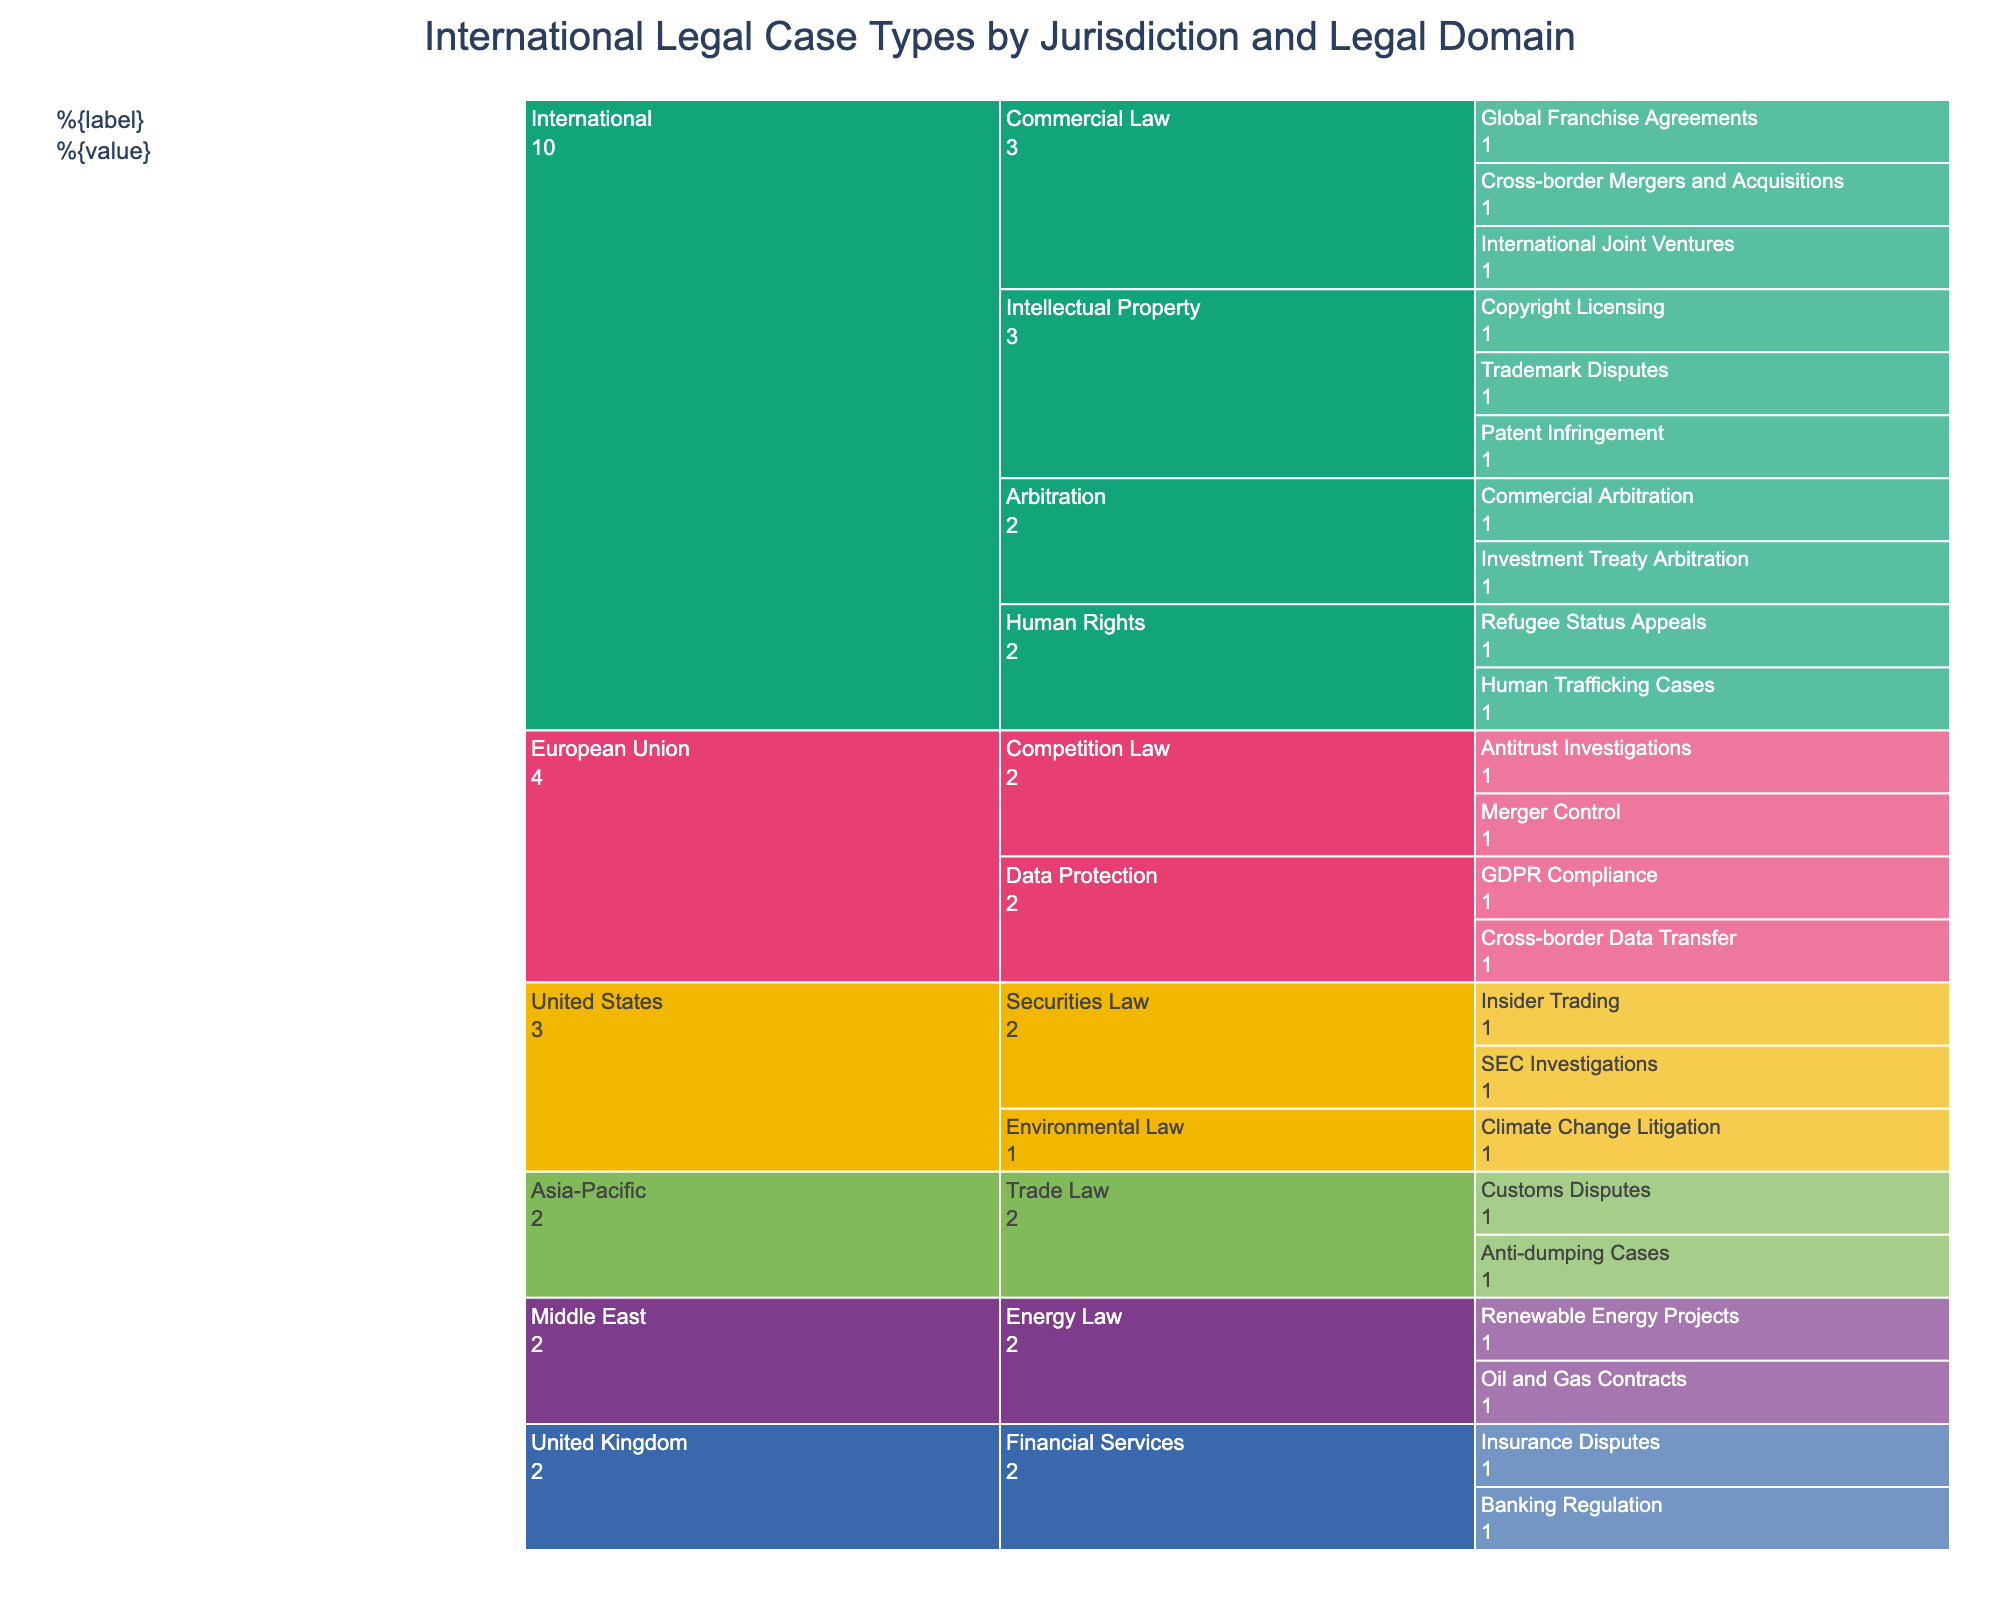What is the title of the icicle chart? The title is located at the top of the chart. It is usually larger and bold to highlight its significance.
Answer: International Legal Case Types by Jurisdiction and Legal Domain Which jurisdiction handles cases related to "Cross-border Mergers and Acquisitions"? To find this, look for where "Cross-border Mergers and Acquisitions" appears within the breakdown of the hierarchical structure. It is categorized under a jurisdiction.
Answer: International How many legal domains are there under the jurisdiction "United Kingdom"? Under the "United Kingdom" section of the hierarchy, each legal domain is a separate branch that can be counted.
Answer: 1 Which legal domain has the most case types in the "European Union" jurisdiction? Observe the branches under the "European Union" jurisdiction. Count the case types under each legal domain and identify which one has the most.
Answer: Competition Law Compare the number of case types related to "Intellectual Property" in the "International" jurisdiction versus "Data Protection" in the "European Union" jurisdiction. Which has more? Count the case types under "Intellectual Property" in the "International" jurisdiction and those under "Data Protection" in the "European Union" jurisdiction. Compare the totals.
Answer: International (3 vs. 2) How many case types are included in the "United States" jurisdiction? Under the "United States" section, count each of the case types listed under its legal domains.
Answer: 4 What percentage of the total case types does the "Arbitration" legal domain represent under the "International" jurisdiction? First, count all case types under "International". Then count case types under "Arbitration". Divide the number of "Arbitration" case types by the total "International" case types and multiply by 100.
Answer: 2 out of 11, ~18.18% Which jurisdictions have only one legal domain represented? Look through each jurisdiction and identify those with a single legal domain branch.
Answer: United Kingdom, Asia-Pacific, Middle East In the "Asia-Pacific" jurisdiction, which types of trade law cases are handled? Under the "Asia-Pacific" jurisdiction branch, look at the subcategories listed directly under "Trade Law".
Answer: Anti-dumping Cases, Customs Disputes 